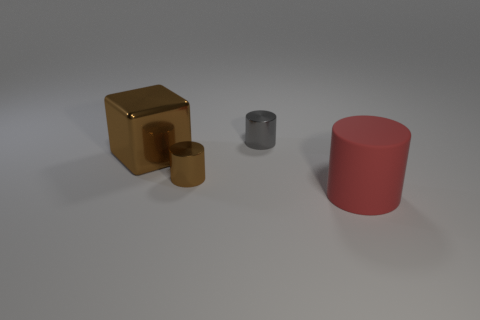Add 1 small green rubber cylinders. How many objects exist? 5 Subtract all cubes. How many objects are left? 3 Subtract all big cylinders. Subtract all red cubes. How many objects are left? 3 Add 2 red objects. How many red objects are left? 3 Add 4 large cylinders. How many large cylinders exist? 5 Subtract 0 purple blocks. How many objects are left? 4 